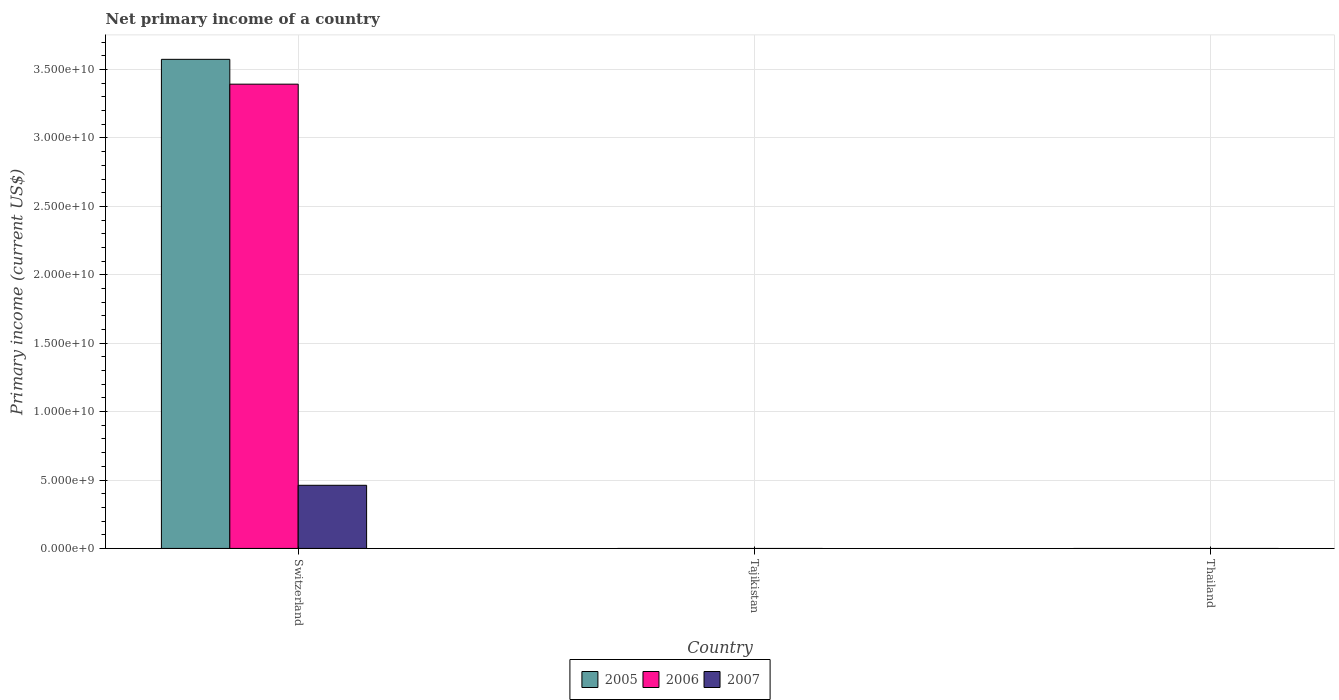How many different coloured bars are there?
Offer a very short reply. 3. Are the number of bars per tick equal to the number of legend labels?
Keep it short and to the point. No. Are the number of bars on each tick of the X-axis equal?
Make the answer very short. No. What is the label of the 1st group of bars from the left?
Offer a very short reply. Switzerland. In how many cases, is the number of bars for a given country not equal to the number of legend labels?
Your answer should be compact. 2. What is the primary income in 2005 in Switzerland?
Offer a terse response. 3.57e+1. Across all countries, what is the maximum primary income in 2006?
Keep it short and to the point. 3.39e+1. Across all countries, what is the minimum primary income in 2006?
Your answer should be compact. 0. In which country was the primary income in 2005 maximum?
Keep it short and to the point. Switzerland. What is the total primary income in 2006 in the graph?
Keep it short and to the point. 3.39e+1. What is the average primary income in 2007 per country?
Ensure brevity in your answer.  1.54e+09. What is the difference between the primary income of/in 2006 and primary income of/in 2005 in Switzerland?
Offer a terse response. -1.82e+09. In how many countries, is the primary income in 2007 greater than 29000000000 US$?
Keep it short and to the point. 0. What is the difference between the highest and the lowest primary income in 2007?
Keep it short and to the point. 4.62e+09. In how many countries, is the primary income in 2005 greater than the average primary income in 2005 taken over all countries?
Keep it short and to the point. 1. Are all the bars in the graph horizontal?
Provide a short and direct response. No. What is the difference between two consecutive major ticks on the Y-axis?
Your answer should be compact. 5.00e+09. Does the graph contain grids?
Your response must be concise. Yes. How are the legend labels stacked?
Keep it short and to the point. Horizontal. What is the title of the graph?
Offer a very short reply. Net primary income of a country. What is the label or title of the X-axis?
Ensure brevity in your answer.  Country. What is the label or title of the Y-axis?
Offer a very short reply. Primary income (current US$). What is the Primary income (current US$) of 2005 in Switzerland?
Give a very brief answer. 3.57e+1. What is the Primary income (current US$) in 2006 in Switzerland?
Make the answer very short. 3.39e+1. What is the Primary income (current US$) in 2007 in Switzerland?
Ensure brevity in your answer.  4.62e+09. What is the Primary income (current US$) in 2005 in Tajikistan?
Give a very brief answer. 0. What is the Primary income (current US$) of 2007 in Tajikistan?
Keep it short and to the point. 0. What is the Primary income (current US$) of 2005 in Thailand?
Keep it short and to the point. 0. Across all countries, what is the maximum Primary income (current US$) in 2005?
Make the answer very short. 3.57e+1. Across all countries, what is the maximum Primary income (current US$) of 2006?
Provide a short and direct response. 3.39e+1. Across all countries, what is the maximum Primary income (current US$) in 2007?
Ensure brevity in your answer.  4.62e+09. Across all countries, what is the minimum Primary income (current US$) of 2005?
Make the answer very short. 0. What is the total Primary income (current US$) in 2005 in the graph?
Your answer should be very brief. 3.57e+1. What is the total Primary income (current US$) in 2006 in the graph?
Offer a very short reply. 3.39e+1. What is the total Primary income (current US$) in 2007 in the graph?
Make the answer very short. 4.62e+09. What is the average Primary income (current US$) of 2005 per country?
Ensure brevity in your answer.  1.19e+1. What is the average Primary income (current US$) in 2006 per country?
Keep it short and to the point. 1.13e+1. What is the average Primary income (current US$) of 2007 per country?
Offer a terse response. 1.54e+09. What is the difference between the Primary income (current US$) of 2005 and Primary income (current US$) of 2006 in Switzerland?
Offer a terse response. 1.82e+09. What is the difference between the Primary income (current US$) in 2005 and Primary income (current US$) in 2007 in Switzerland?
Offer a very short reply. 3.11e+1. What is the difference between the Primary income (current US$) of 2006 and Primary income (current US$) of 2007 in Switzerland?
Your answer should be very brief. 2.93e+1. What is the difference between the highest and the lowest Primary income (current US$) in 2005?
Ensure brevity in your answer.  3.57e+1. What is the difference between the highest and the lowest Primary income (current US$) of 2006?
Make the answer very short. 3.39e+1. What is the difference between the highest and the lowest Primary income (current US$) of 2007?
Provide a succinct answer. 4.62e+09. 